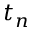Convert formula to latex. <formula><loc_0><loc_0><loc_500><loc_500>t _ { n }</formula> 